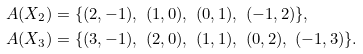<formula> <loc_0><loc_0><loc_500><loc_500>\ A ( X _ { 2 } ) & = \{ ( 2 , - 1 ) , \ ( 1 , 0 ) , \ ( 0 , 1 ) , \ ( - 1 , 2 ) \} , \\ A ( X _ { 3 } ) & = \{ ( 3 , - 1 ) , \ ( 2 , 0 ) , \ ( 1 , 1 ) , \ ( 0 , 2 ) , \ ( - 1 , 3 ) \} .</formula> 